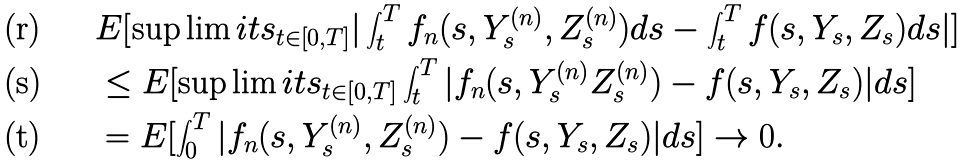<formula> <loc_0><loc_0><loc_500><loc_500>& E [ \sup \lim i t s _ { t \in [ 0 , T ] } | \int ^ { T } _ { t } f _ { n } ( s , Y ^ { ( n ) } _ { s } , Z ^ { ( n ) } _ { s } ) d s - \int ^ { T } _ { t } f ( s , Y _ { s } , Z _ { s } ) d s | ] \\ & \leq E [ \sup \lim i t s _ { t \in [ 0 , T ] } \int ^ { T } _ { t } | f _ { n } ( s , Y ^ { ( n ) } _ { s } Z ^ { ( n ) } _ { s } ) - f ( s , Y _ { s } , Z _ { s } ) | d s ] \\ & = E [ \int ^ { T } _ { 0 } | f _ { n } ( s , Y ^ { ( n ) } _ { s } , Z ^ { ( n ) } _ { s } ) - f ( s , Y _ { s } , Z _ { s } ) | d s ] \rightarrow 0 .</formula> 